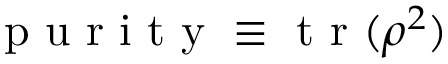Convert formula to latex. <formula><loc_0><loc_0><loc_500><loc_500>p u r i t y \equiv t r ( \rho ^ { 2 } )</formula> 